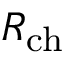<formula> <loc_0><loc_0><loc_500><loc_500>R _ { c h }</formula> 